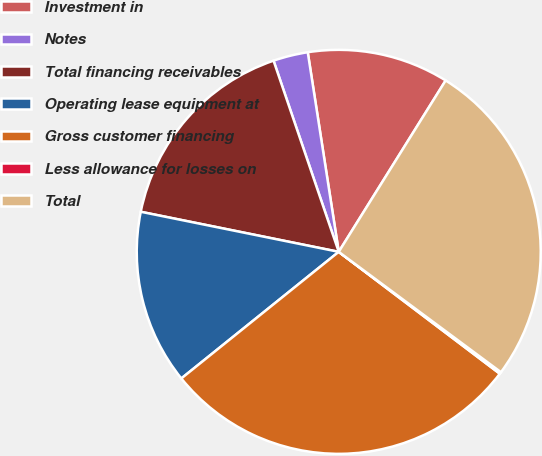<chart> <loc_0><loc_0><loc_500><loc_500><pie_chart><fcel>Investment in<fcel>Notes<fcel>Total financing receivables<fcel>Operating lease equipment at<fcel>Gross customer financing<fcel>Less allowance for losses on<fcel>Total<nl><fcel>11.33%<fcel>2.78%<fcel>16.59%<fcel>13.96%<fcel>28.91%<fcel>0.15%<fcel>26.28%<nl></chart> 